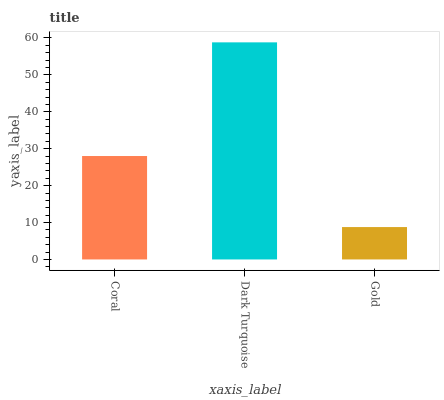Is Gold the minimum?
Answer yes or no. Yes. Is Dark Turquoise the maximum?
Answer yes or no. Yes. Is Dark Turquoise the minimum?
Answer yes or no. No. Is Gold the maximum?
Answer yes or no. No. Is Dark Turquoise greater than Gold?
Answer yes or no. Yes. Is Gold less than Dark Turquoise?
Answer yes or no. Yes. Is Gold greater than Dark Turquoise?
Answer yes or no. No. Is Dark Turquoise less than Gold?
Answer yes or no. No. Is Coral the high median?
Answer yes or no. Yes. Is Coral the low median?
Answer yes or no. Yes. Is Gold the high median?
Answer yes or no. No. Is Gold the low median?
Answer yes or no. No. 